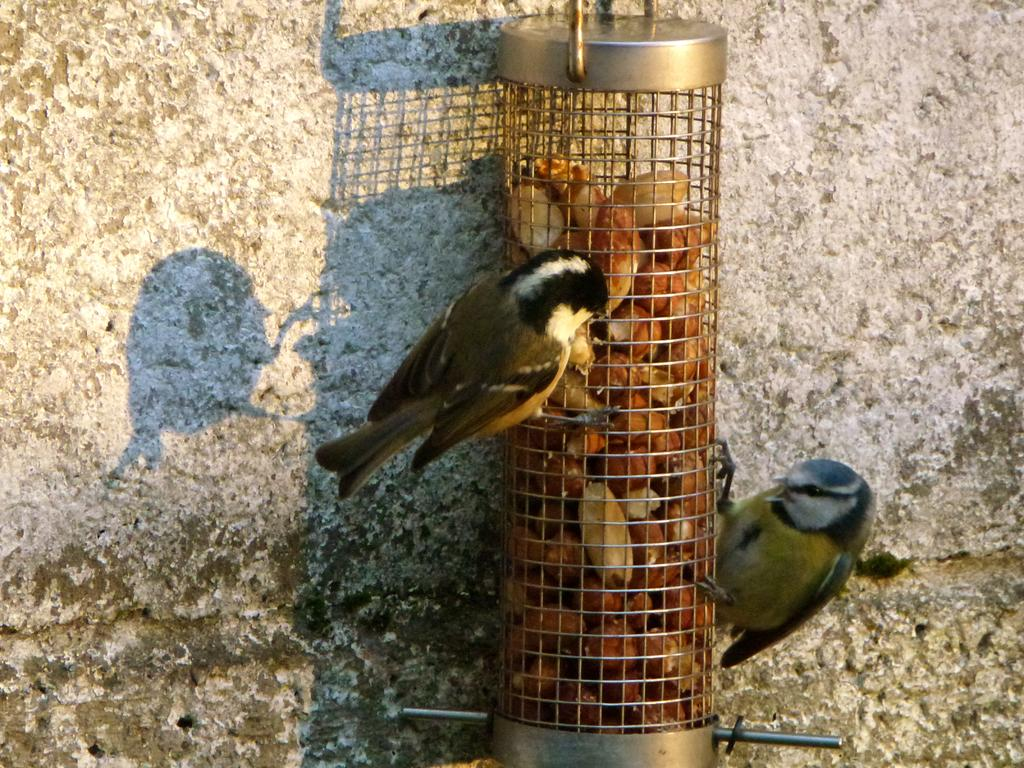What type of container is holding the food items in the image? The food items are in a metal object. What other living creatures can be seen in the image? Birds are present on the metal object. What is visible in the background of the image? There is a wall in the background of the image. What type of slave is depicted in the image? There is no depiction of a slave in the image; it features food items in a metal object and birds on the metal object. What type of home is shown in the image? There is no home depicted in the image; it features food items in a metal object, birds on the metal object, and a wall in the background. 